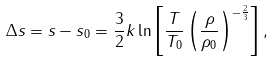<formula> <loc_0><loc_0><loc_500><loc_500>\Delta s = s - s _ { 0 } = \frac { 3 } { 2 } k \ln \left [ \frac { T } { T _ { 0 } } \left ( \frac { \rho } { \rho _ { 0 } } \right ) ^ { - \frac { 2 } { 3 } } \right ] ,</formula> 